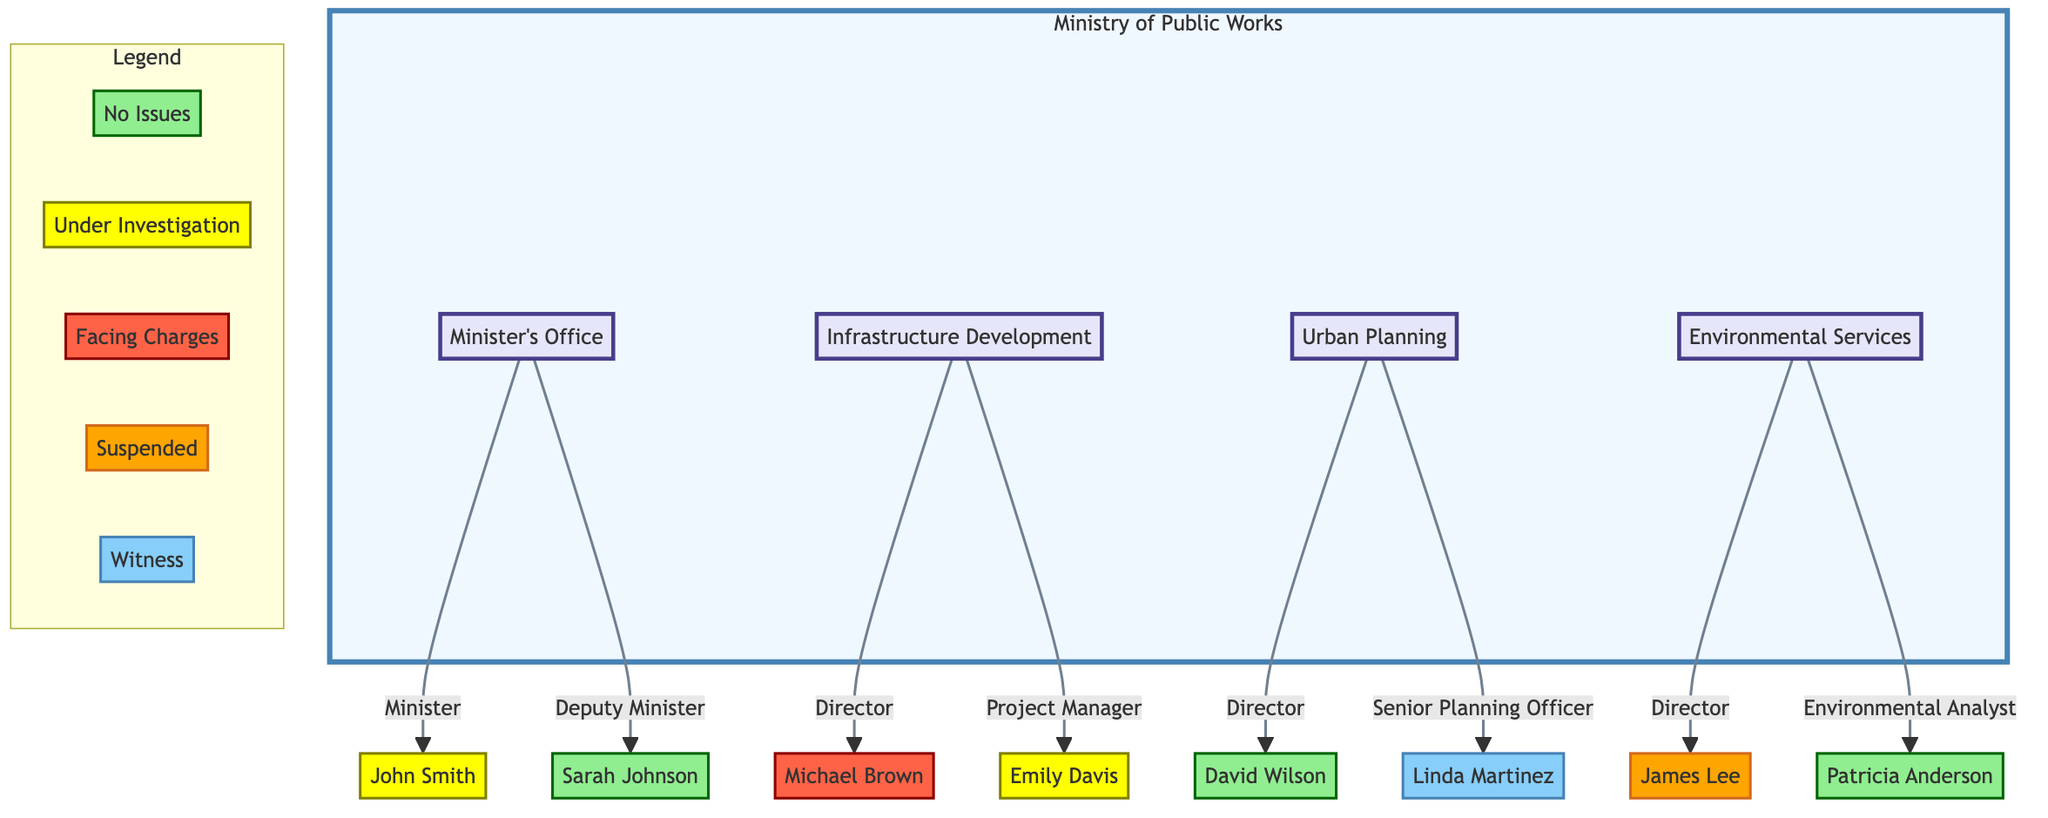What is the status of John Smith? John Smith is located under the Minister's Office node and is annotated with the "Under Investigation" status, which indicates he is currently being investigated for potential misconduct.
Answer: Under Investigation How many directors are there in the Infrastructure Development and Environmental Services departments? Infrastructure Development has 1 director (Michael Brown) and Environmental Services also has 1 director (James Lee), making a total of 2 directors in these departments.
Answer: 2 Who is suspended in the Environmental Services department? In the Environmental Services department, the status of James Lee is annotated as "Suspended," indicating he has been temporarily removed from his position.
Answer: James Lee What role does Emily Davis hold? Emily Davis is identified under the Infrastructure Development department as a "Project Manager," indicating her specific position within this structure.
Answer: Project Manager Who is the witness in the Urban Planning department? Under the Urban Planning department, Linda Martinez is labeled as "Witness," showing her role involves providing information about potential corrupt practices without being officially charged.
Answer: Linda Martinez How many officials in the diagram have no issues? The diagram indicates that Sarah Johnson, David Wilson, and Patricia Anderson are labeled with "No Issues," totaling to 3 officials without any known problems.
Answer: 3 What is the combined status of officials in the Infrastructure Development department? Within the Infrastructure Development department, Michael Brown is "Facing Charges," and Emily Davis is "Under Investigation," indicating a serious concern regarding the integrity of this department.
Answer: Facing Charges, Under Investigation Which departments have officials currently facing charges? The only official facing charges is Michael Brown, from the Infrastructure Development department, indicating that this department is scrutinized for corruption issues.
Answer: Infrastructure Development How many nodes are represented under the Ministry of Public Works? The Ministry of Public Works contains 7 nodes in total: the Minister's Office (2 nodes), Infrastructure Development (2 nodes), Urban Planning (2 nodes), and Environmental Services (2 nodes), resulting in 8 nodes including the departments themselves.
Answer: 8 